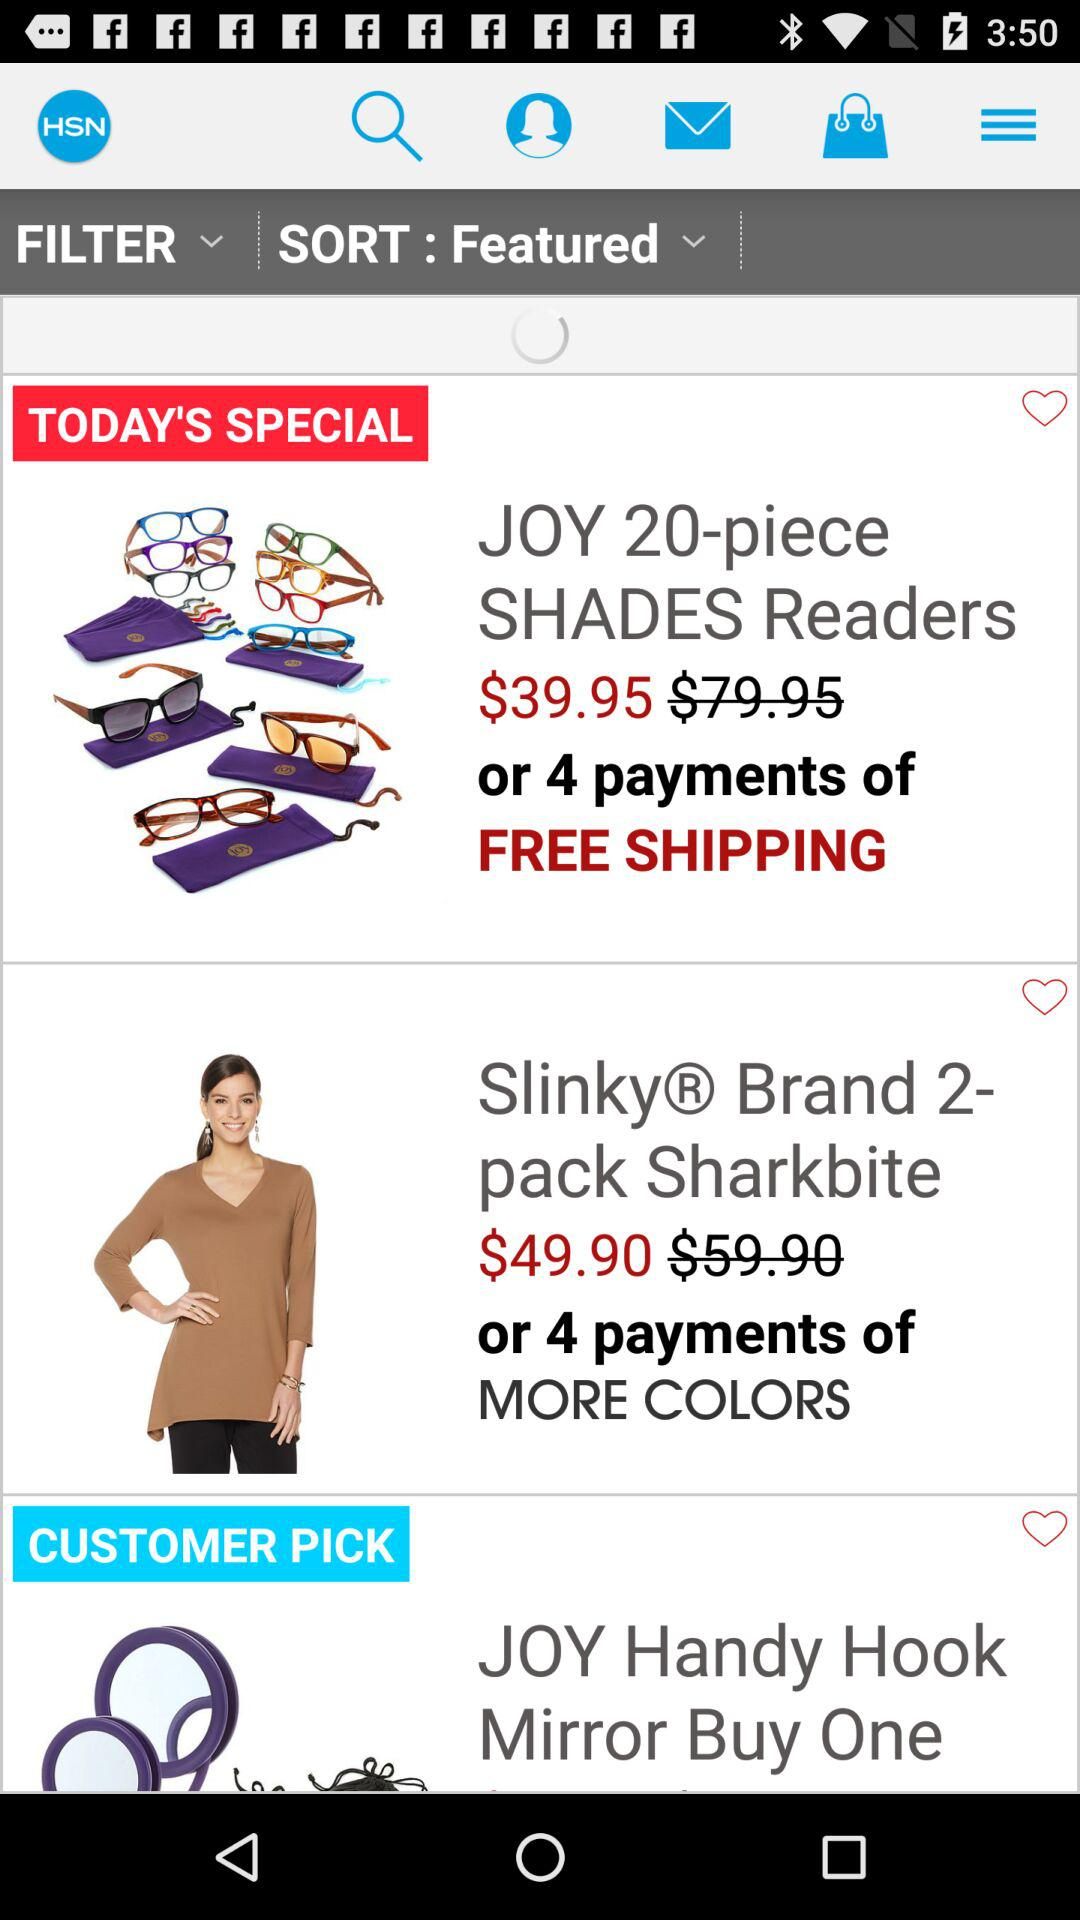What is the discounted price of the Joy 20-piece shades readers? The discounted price of the Joy 20-piece shades readers is $39.95. 